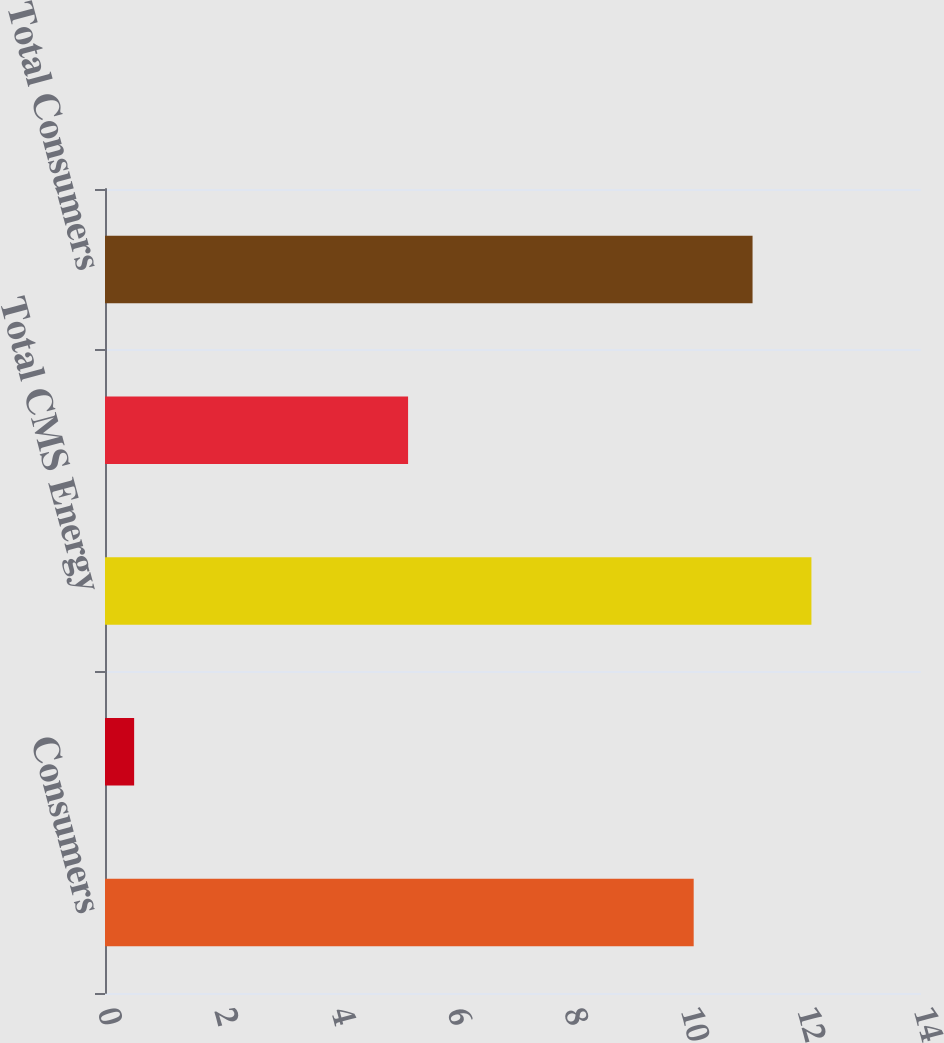Convert chart to OTSL. <chart><loc_0><loc_0><loc_500><loc_500><bar_chart><fcel>Consumers<fcel>Enterprises<fcel>Total CMS Energy<fcel>Electric utility operations<fcel>Total Consumers<nl><fcel>10.1<fcel>0.5<fcel>12.12<fcel>5.2<fcel>11.11<nl></chart> 